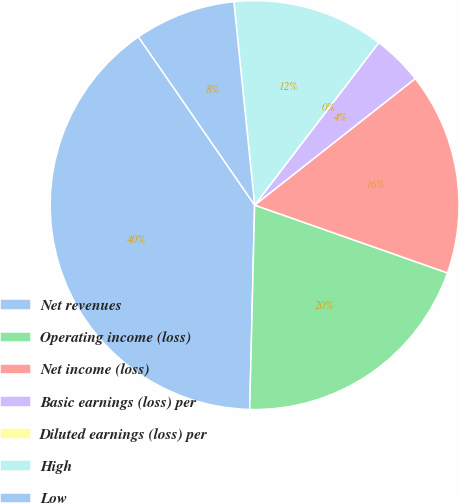Convert chart. <chart><loc_0><loc_0><loc_500><loc_500><pie_chart><fcel>Net revenues<fcel>Operating income (loss)<fcel>Net income (loss)<fcel>Basic earnings (loss) per<fcel>Diluted earnings (loss) per<fcel>High<fcel>Low<nl><fcel>40.0%<fcel>20.0%<fcel>16.0%<fcel>4.0%<fcel>0.0%<fcel>12.0%<fcel>8.0%<nl></chart> 